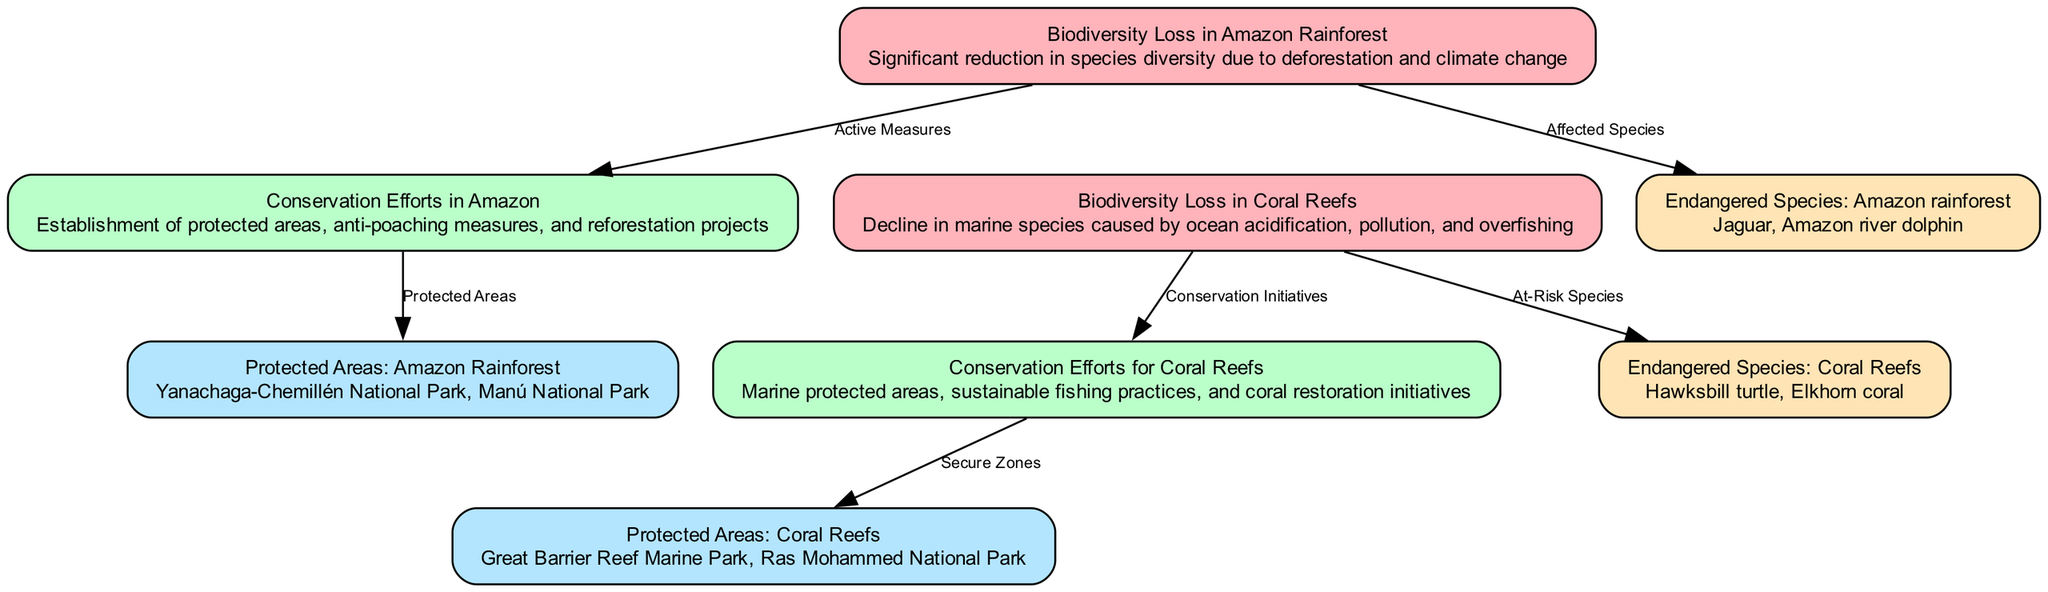What is one of the conservation efforts in the Amazon? The diagram indicates that one of the conservation efforts in the Amazon is the establishment of protected areas. This specific information is found in the node labeled "Conservation Efforts in Amazon."
Answer: Establishment of protected areas How many endangered species are listed for the Coral Reefs? The diagram shows one node specifically under “Endangered Species: Coral Reefs.” Since there are two species mentioned within that node (Hawksbill turtle and Elkhorn coral), the answer is derived from counting these listed species.
Answer: Two What are the protected areas in the Coral Reefs? The node contains the description under "Protected Areas: Coral Reefs," which lists Great Barrier Reef Marine Park and Ras Mohammed National Park as the specific areas. This information is directly accessible from the diagram.
Answer: Great Barrier Reef Marine Park, Ras Mohammed National Park What connects "Biodiversity Loss in Coral Reefs" to its conservation efforts? The connection between "Biodiversity Loss in Coral Reefs" and its conservation efforts is represented by an edge labeled "Conservation Initiatives." This edge signifies the active measures taken to mitigate the loss in that area.
Answer: Conservation Initiatives Which species are identified as endangered in the Amazon rainforest? The diagram identifies two endangered species specifically in the Amazon rainforest: Jaguar and Amazon river dolphin. This is gathered by referring to the node that discusses endangered species in that region.
Answer: Jaguar, Amazon river dolphin What are the effects of deforestation mentioned in the Amazon section? The diagram states that there is a significant reduction in species diversity due to deforestation among other factors in "Biodiversity Loss in Amazon Rainforest." Hence, understanding the content of this node helps clarify the effects.
Answer: Significant reduction in species diversity Which marine conservation efforts are indicated in the diagram? The diagram lists several efforts under "Conservation Efforts for Coral Reefs," such as marine protected areas, sustainable fishing practices, and coral restoration initiatives. This is collected from the contents of that specific node on conservation efforts.
Answer: Marine protected areas, sustainable fishing practices, coral restoration initiatives How many edges connect biodiversity loss to conservation efforts for the Amazon? From the Amazon section of the diagram, there is one edge that connects biodiversity loss ("Biodiversity Loss in Amazon Rainforest") to its conservation efforts ("Conservation Efforts in Amazon"). Therefore, counting edges directly reveals this information.
Answer: One What is the alternative labeling for the species affected by biodiversity loss in the Amazon? The species specifically listed as affected in the Amazon are labeled under "Affected Species" and include the Jaguar and Amazon river dolphin. This is identified by referencing the respective edge and node connections in the diagram.
Answer: Jaguar, Amazon river dolphin 